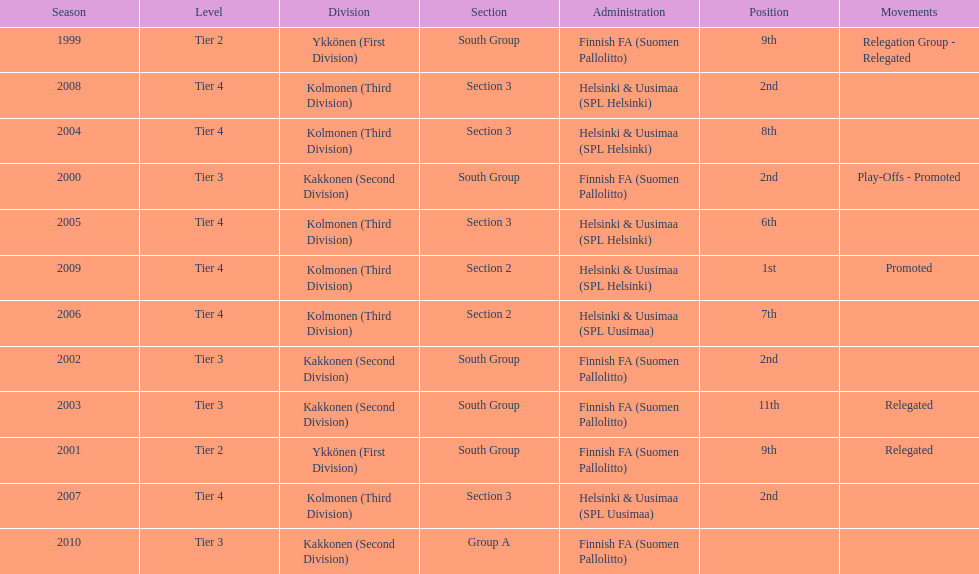In which most recent year did they achieve a 2nd place finish? 2008. 